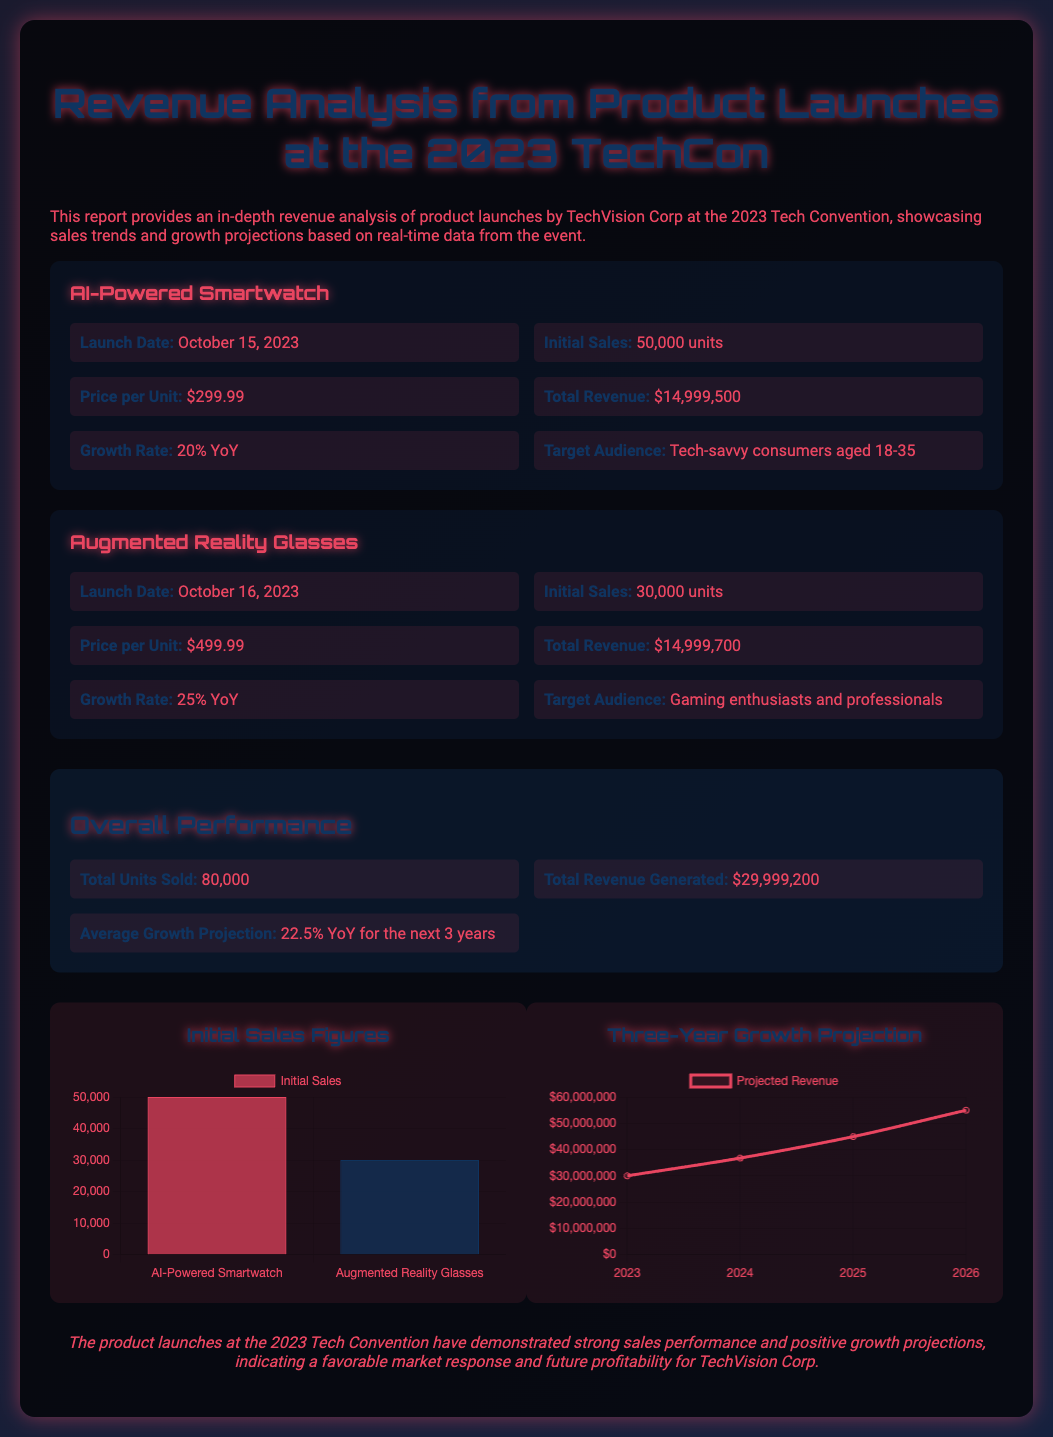What is the launch date of the AI-Powered Smartwatch? The launch date is specifically mentioned in the section about the AI-Powered Smartwatch.
Answer: October 15, 2023 What is the growth rate of the Augmented Reality Glasses? The growth rate is provided alongside the revenue data for the Augmented Reality Glasses.
Answer: 25% YoY What is the total revenue generated from both product launches? The total revenue generated sums up the revenues from each product launch, as mentioned in the overall performance section.
Answer: $29,999,200 How many units of the AI-Powered Smartwatch were initially sold? The initial sales figure is specified in the product launch details of the AI-Powered Smartwatch.
Answer: 50,000 units What is the average growth projection for the next three years? The average growth projection is explicitly stated in the overall performance section of the document.
Answer: 22.5% YoY for the next 3 years What was the price per unit for the Augmented Reality Glasses? The price per unit is listed in the details of the Augmented Reality Glasses product launch.
Answer: $499.99 What is the initial sales figure for the AI-Powered Smartwatch? The initial sales figure is mentioned under the AI-Powered Smartwatch launch details.
Answer: 50,000 units What is the total number of units sold across both products? The total units sold is summarized in the overall performance section.
Answer: 80,000 What type of chart is used to represent initial sales figures? The chart type is mentioned in relation to the data visualization section of the document.
Answer: Bar 